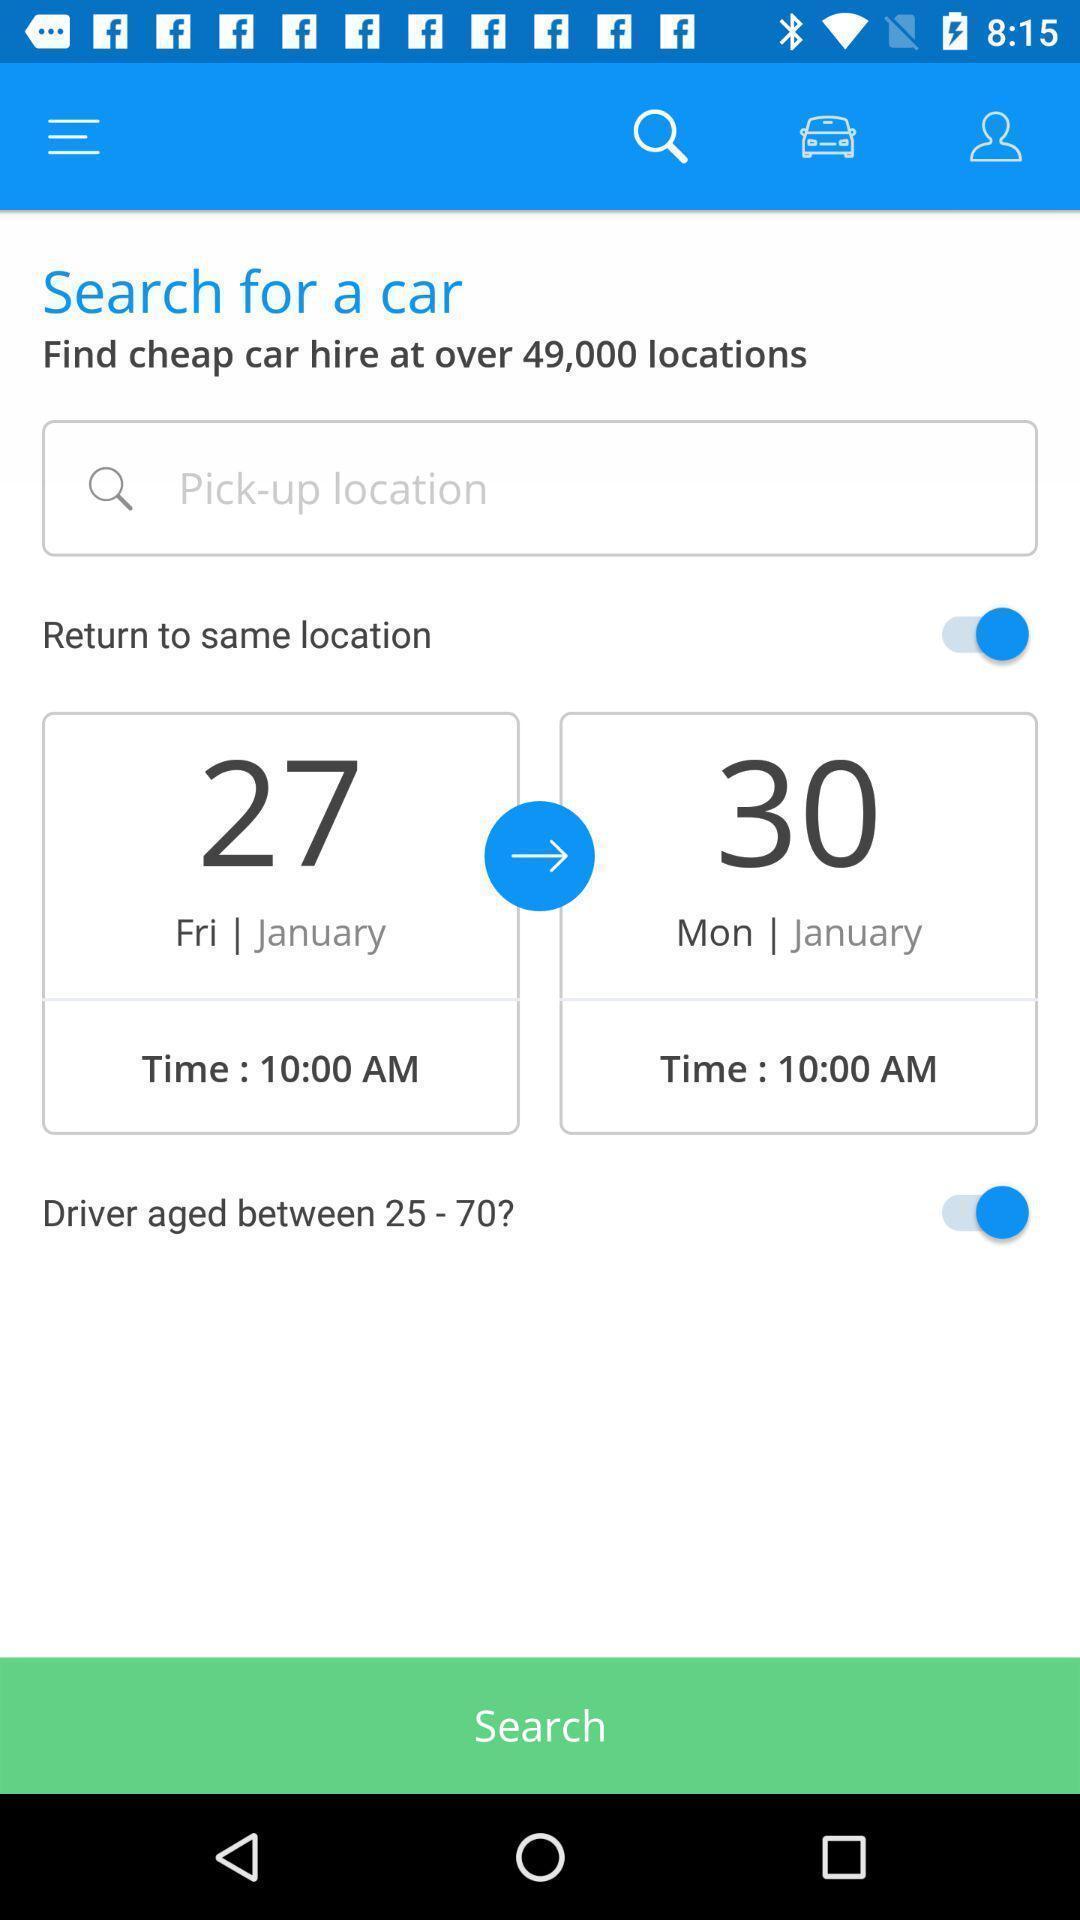Tell me what you see in this picture. Search page of an car rental app. 